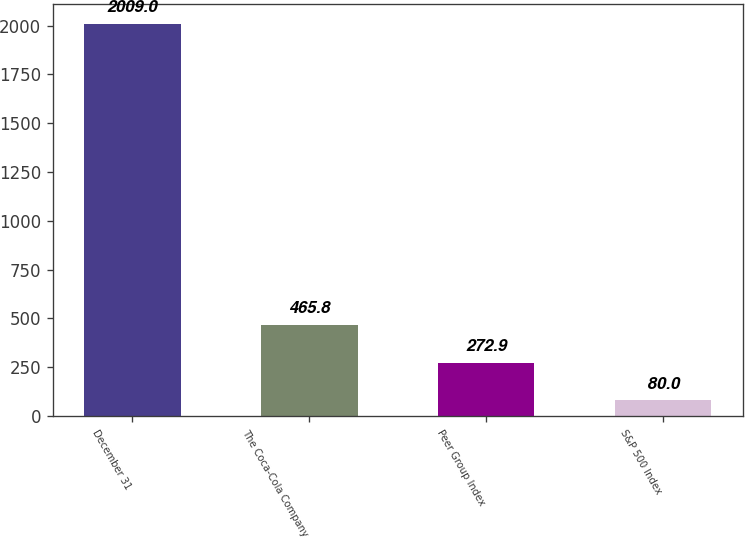Convert chart. <chart><loc_0><loc_0><loc_500><loc_500><bar_chart><fcel>December 31<fcel>The Coca-Cola Company<fcel>Peer Group Index<fcel>S&P 500 Index<nl><fcel>2009<fcel>465.8<fcel>272.9<fcel>80<nl></chart> 